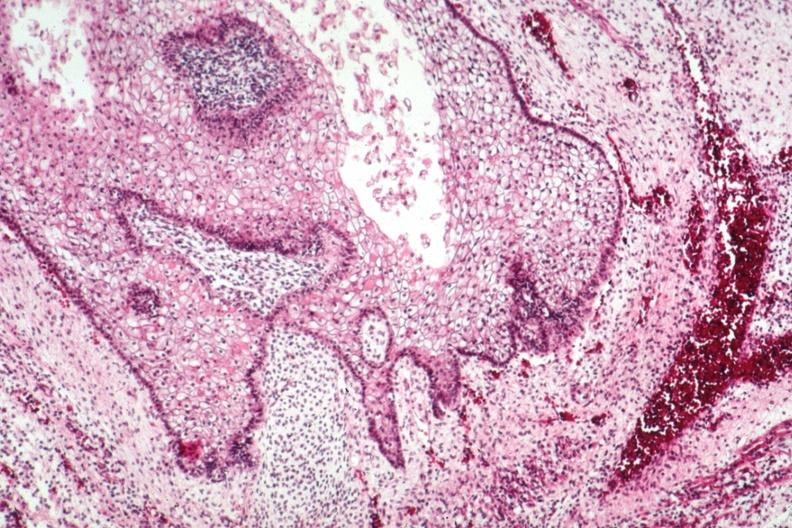does this image show squamous epithelial component?
Answer the question using a single word or phrase. Yes 